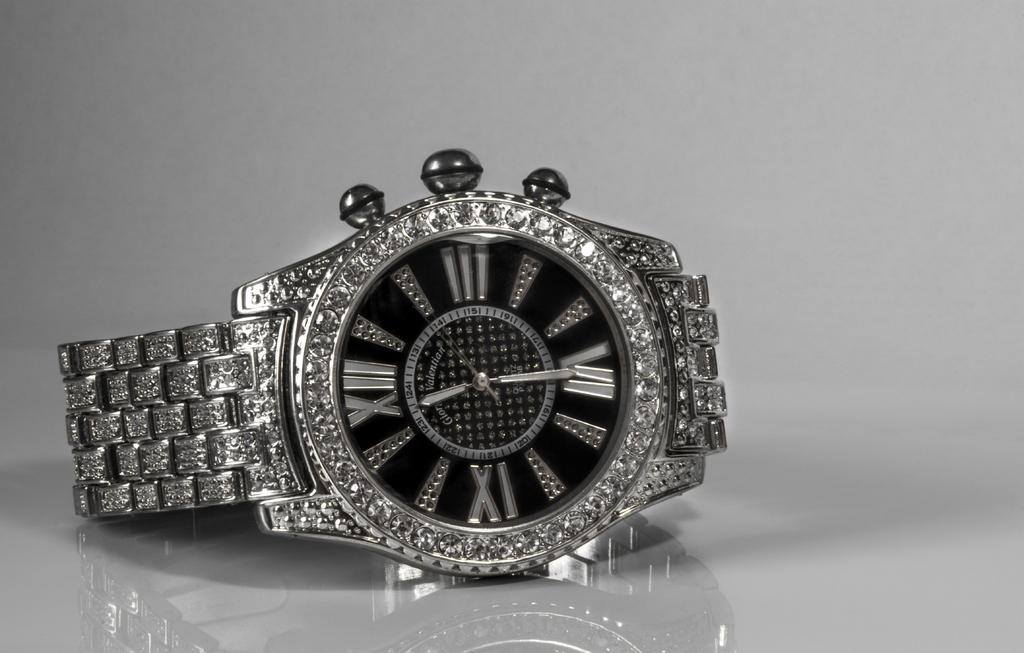<image>
Write a terse but informative summary of the picture. A silver watch with the word Valentian on the face of the watch. 